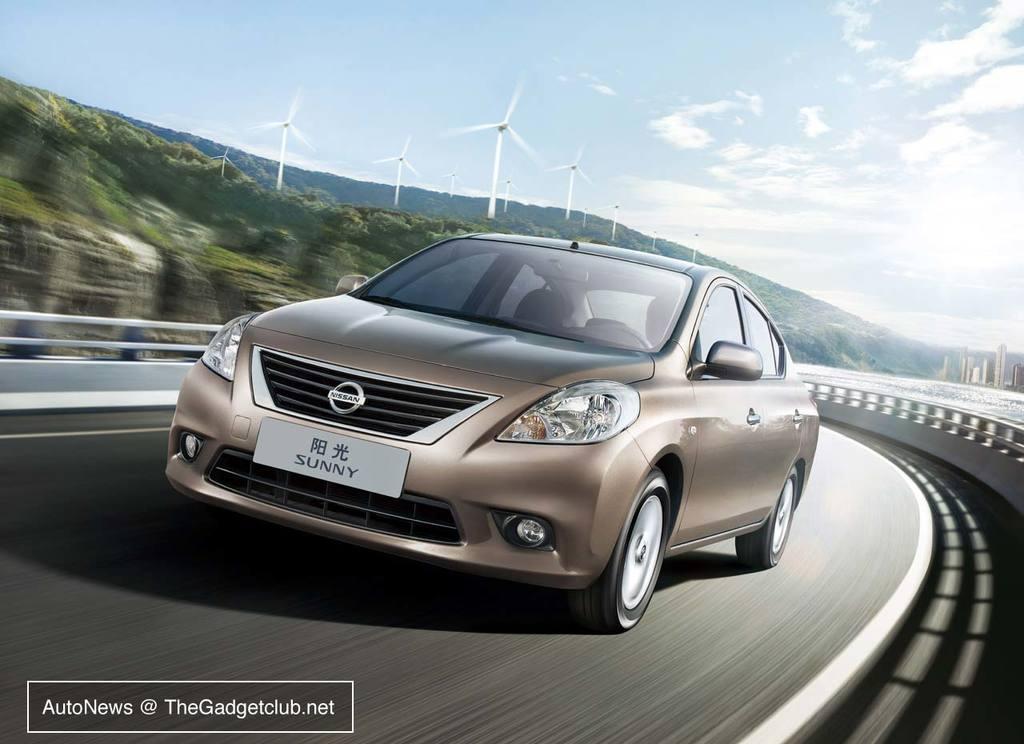How would you summarize this image in a sentence or two? In this image we can see a car is moving on the road, behind the car forest is there and turbines are present. The sky is in blue color with some clouds. 